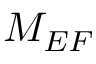Convert formula to latex. <formula><loc_0><loc_0><loc_500><loc_500>M _ { E F }</formula> 